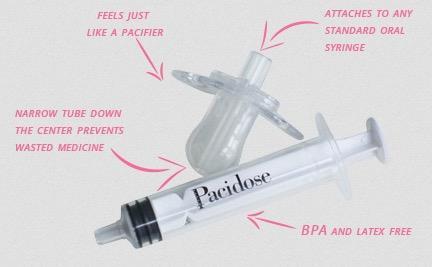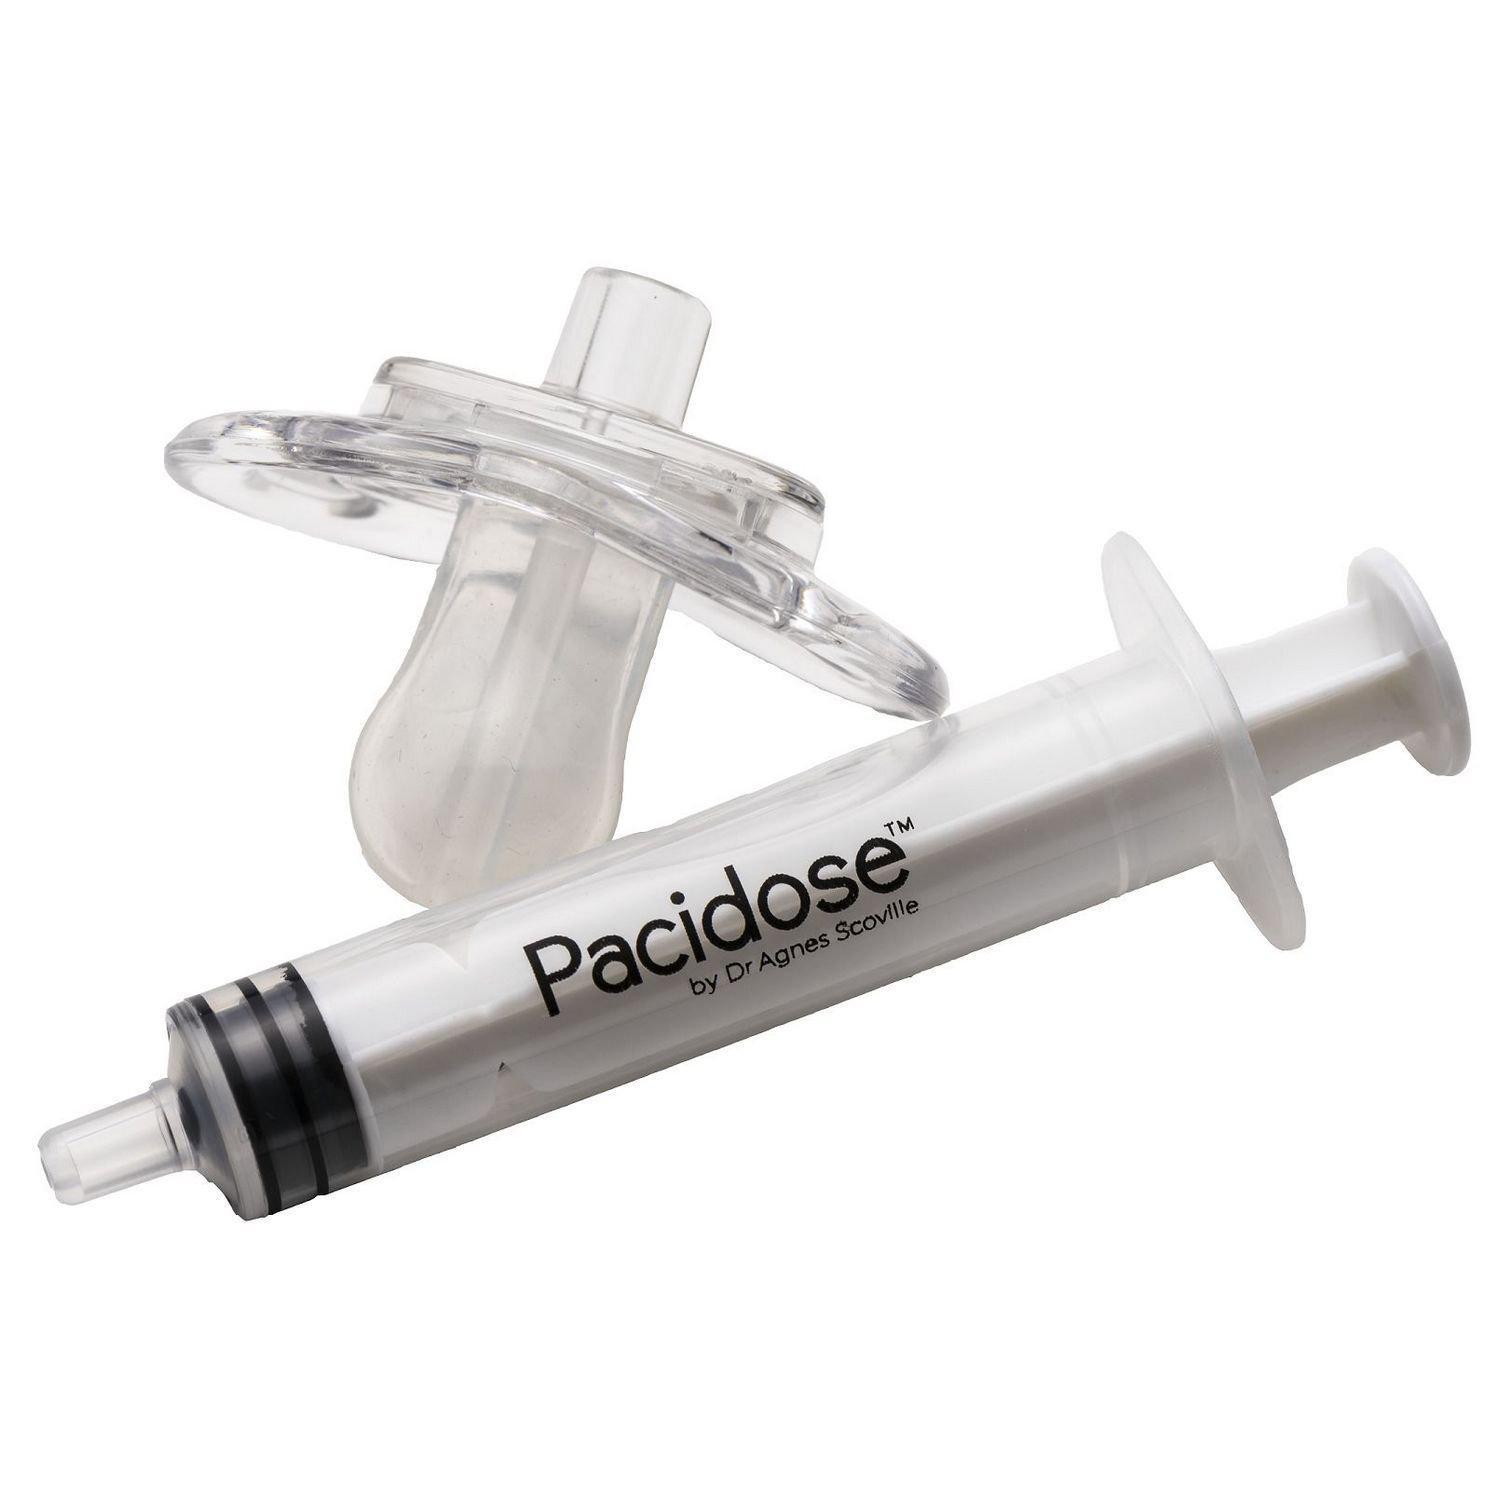The first image is the image on the left, the second image is the image on the right. Given the left and right images, does the statement "At least one image includes an item resembling a pacifier next to a syringe." hold true? Answer yes or no. Yes. The first image is the image on the left, the second image is the image on the right. Assess this claim about the two images: "The left image has a syringe with a nozzle, the right image has at least three syringes, and no image has a pacifier.". Correct or not? Answer yes or no. No. 